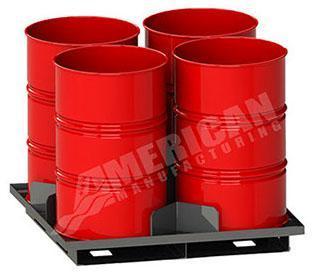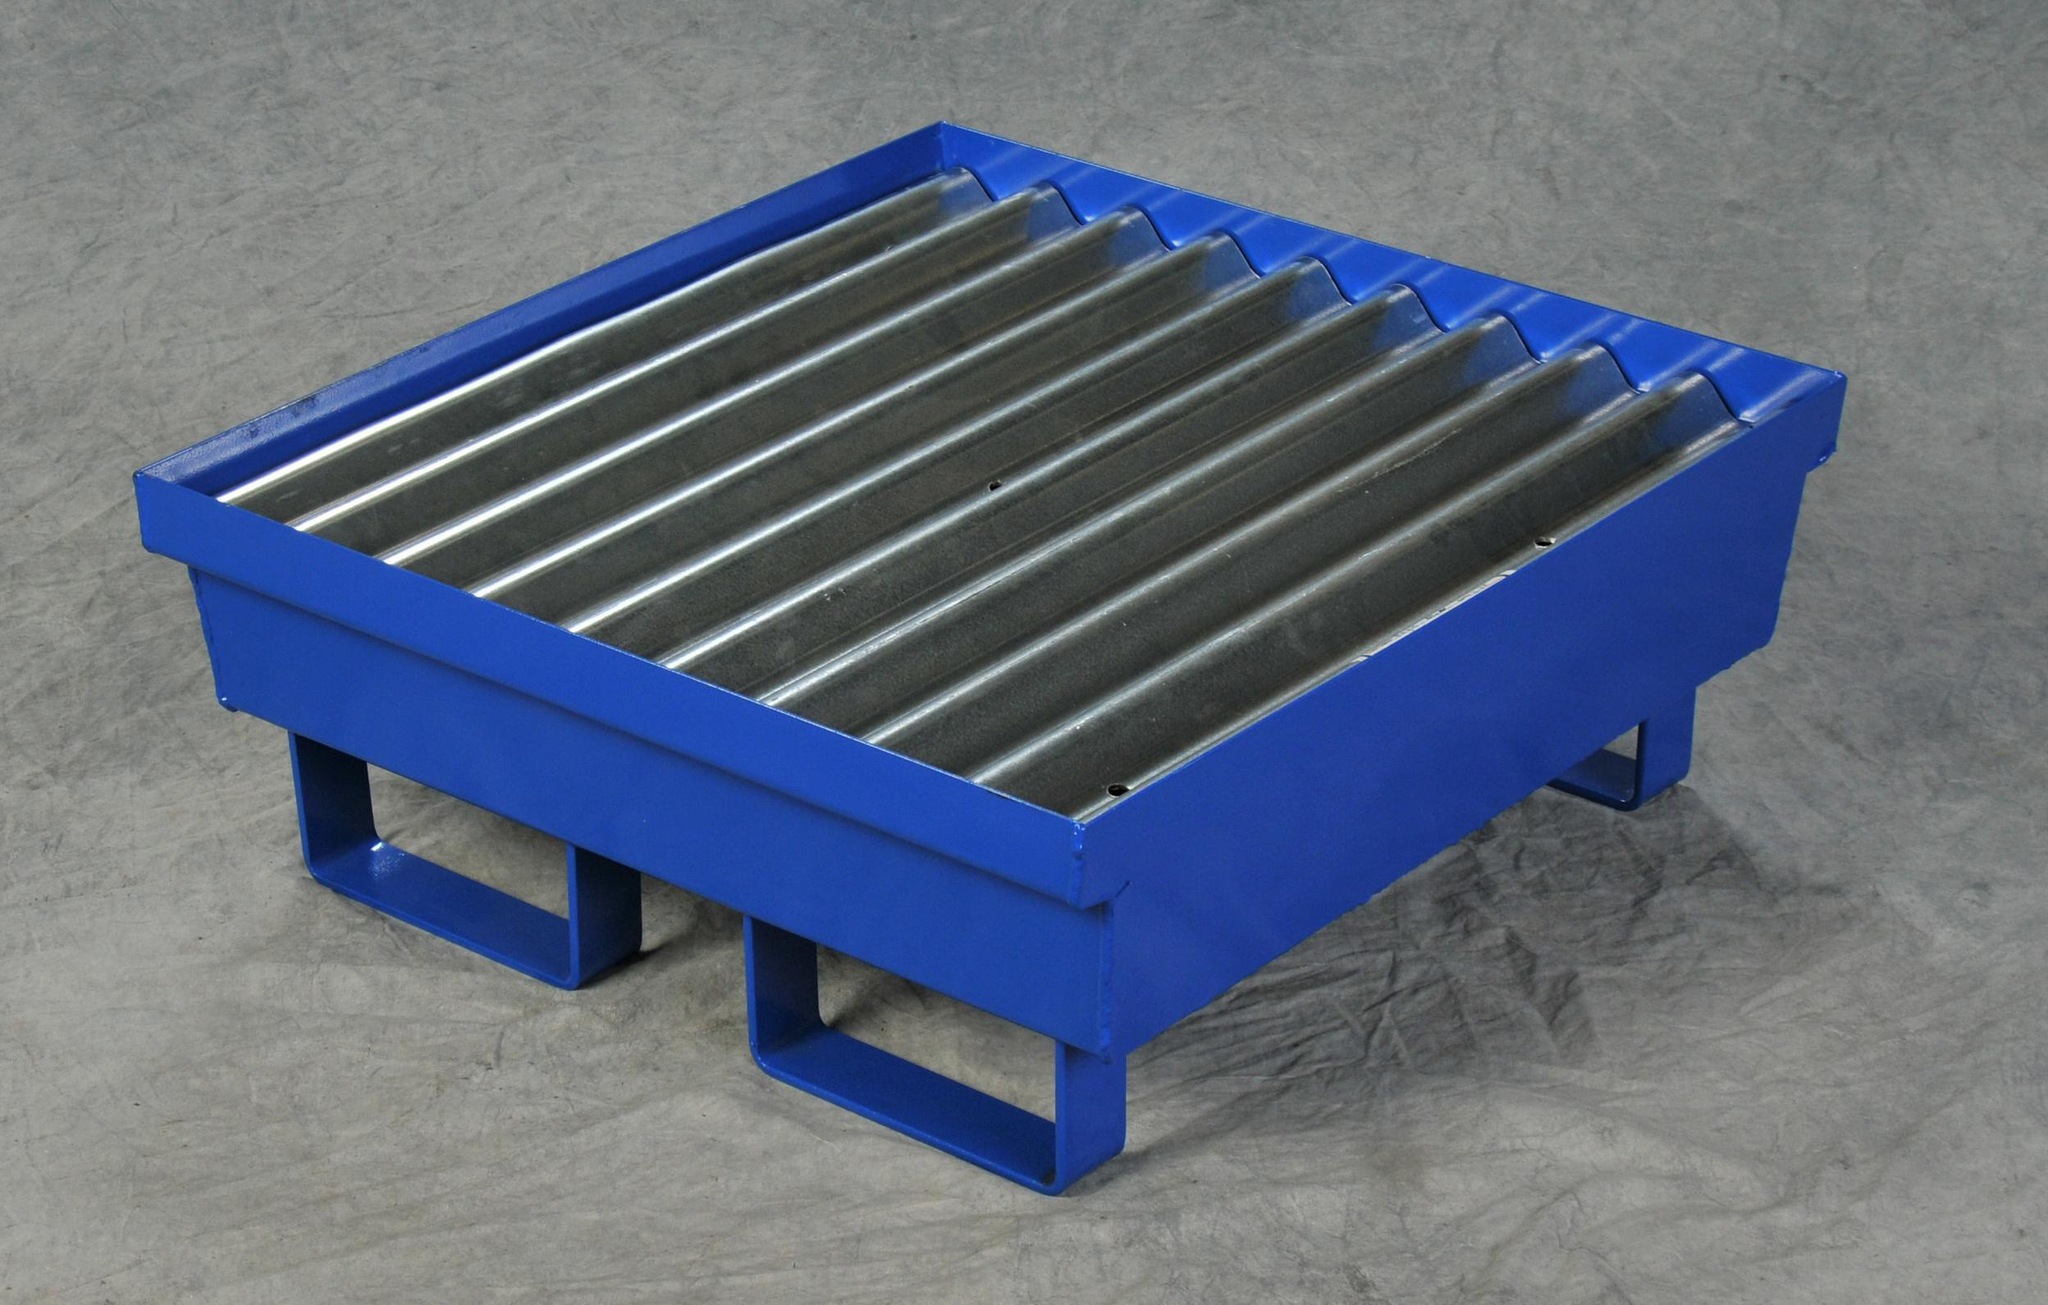The first image is the image on the left, the second image is the image on the right. Examine the images to the left and right. Is the description "Red barrels sit in a black metal fenced container with chains on one side in one of the images." accurate? Answer yes or no. No. The first image is the image on the left, the second image is the image on the right. Analyze the images presented: Is the assertion "One image shows at least one cube-shaped black frame that contains four upright red barrels on a blue base." valid? Answer yes or no. No. 